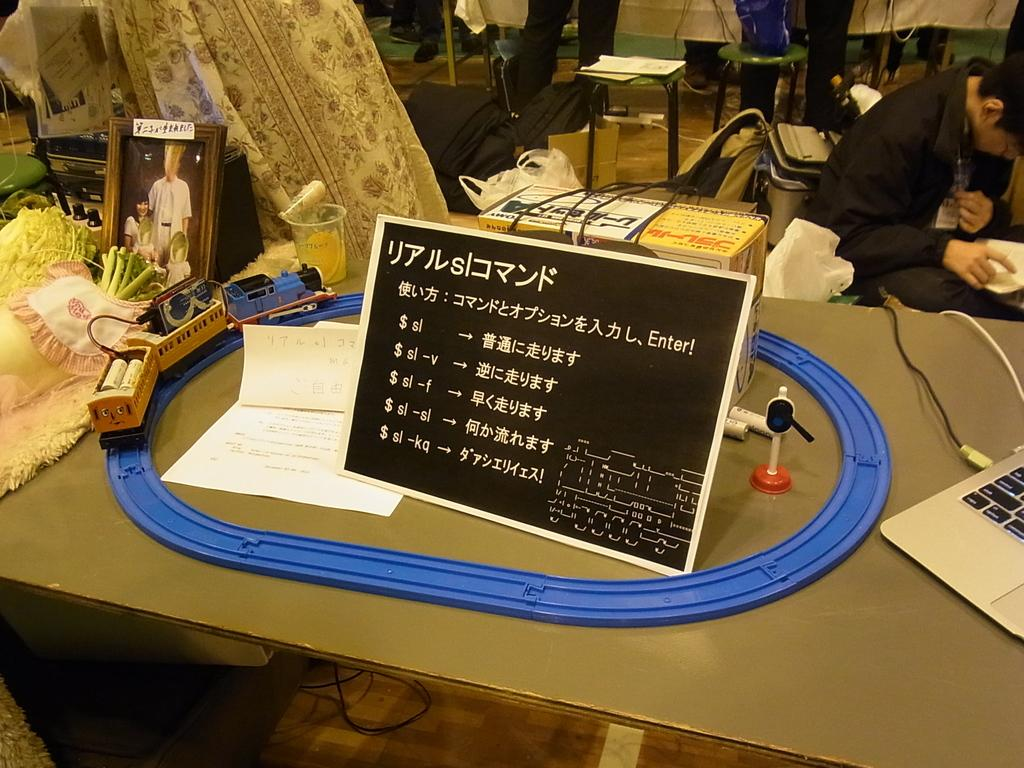What is the main object in the image? There is a board in the image. What else can be seen on the board? There are papers on the board. Are there any other objects visible in the image? Yes, there is a toy, a photo frame, and a glass in the image. What is the general setting of the image? There are things on the table, and there is a person sitting on a chair in the background of the image. What can be seen in the background of the image? There is a table, a chair, and a cover in the background of the image. How much dust is visible on the brick in the image? There is no brick present in the image, so it is not possible to determine the amount of dust on it. 